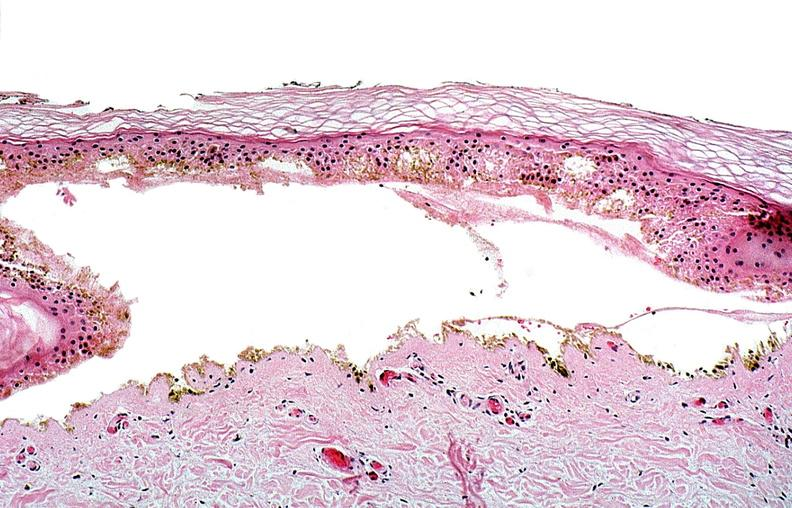does this image show thermal burned skin?
Answer the question using a single word or phrase. Yes 